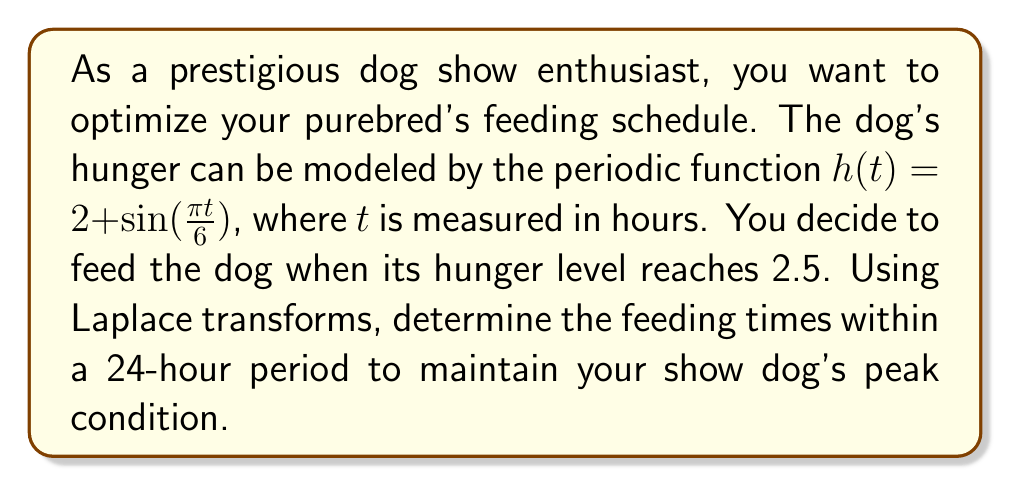Could you help me with this problem? Let's approach this step-by-step:

1) We need to find the times when $h(t) = 2.5$. This means solving:

   $2 + \sin(\frac{\pi t}{6}) = 2.5$

2) Simplifying:

   $\sin(\frac{\pi t}{6}) = 0.5$

3) Taking the arcsin of both sides:

   $\frac{\pi t}{6} = \arcsin(0.5) + 2\pi n$, where $n$ is an integer

4) Solving for $t$:

   $t = \frac{6}{\pi}(\arcsin(0.5) + 2\pi n)$

5) We know that $\arcsin(0.5) = \frac{\pi}{6}$, so:

   $t = 6(\frac{1}{6} + 2n) = 1 + 12n$

6) For a 24-hour period, we need $n = 0$ and $n = 1$:

   When $n = 0$, $t = 1$
   When $n = 1$, $t = 13$

7) To verify using Laplace transforms:

   $\mathcal{L}\{h(t)\} = \mathcal{L}\{2 + \sin(\frac{\pi t}{6})\}$
   
   $= \frac{2}{s} + \frac{\frac{\pi}{6}}{s^2 + (\frac{\pi}{6})^2}$

8) The periodic nature of the function is confirmed by the presence of $s^2$ in the denominator of the Laplace transform.

9) The period of the function is:

   $T = \frac{2\pi}{\frac{\pi}{6}} = 12$ hours

This confirms our calculation that the feeding times are 12 hours apart.
Answer: The optimal feeding times within a 24-hour period are at $t = 1$ hour and $t = 13$ hours. 